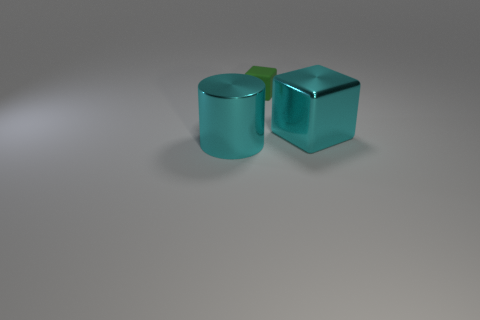Can you describe the shapes of the objects in the image? Certainly, there are two objects in the image: one object is cylindrical in shape while the other is cubic. The shapes are defined by smooth, clear edges and surfaces that reflect light. 